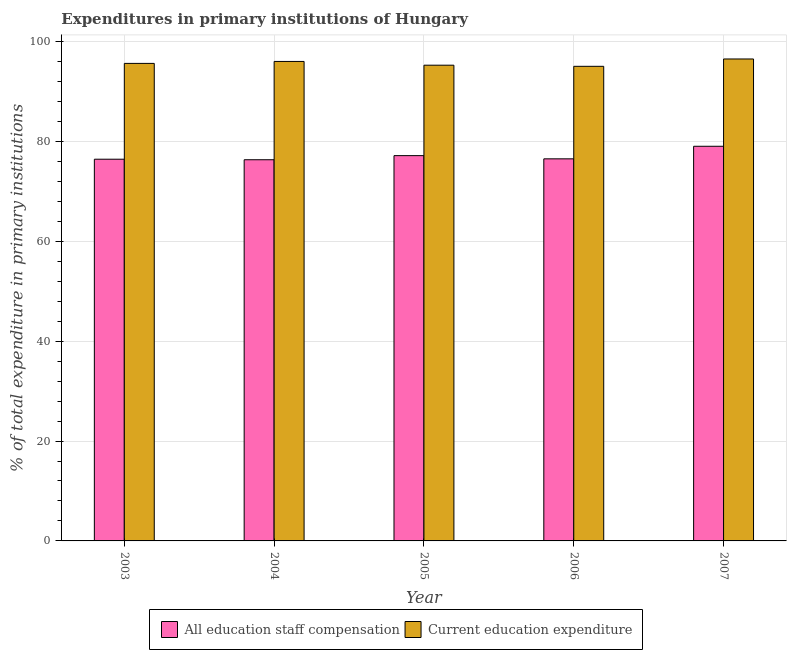How many different coloured bars are there?
Your answer should be compact. 2. Are the number of bars per tick equal to the number of legend labels?
Your answer should be compact. Yes. What is the label of the 1st group of bars from the left?
Your answer should be compact. 2003. What is the expenditure in staff compensation in 2006?
Your response must be concise. 76.5. Across all years, what is the maximum expenditure in education?
Your answer should be very brief. 96.49. Across all years, what is the minimum expenditure in staff compensation?
Offer a very short reply. 76.32. In which year was the expenditure in education maximum?
Keep it short and to the point. 2007. In which year was the expenditure in staff compensation minimum?
Your answer should be compact. 2004. What is the total expenditure in education in the graph?
Keep it short and to the point. 478.37. What is the difference between the expenditure in staff compensation in 2004 and that in 2005?
Keep it short and to the point. -0.82. What is the difference between the expenditure in education in 2003 and the expenditure in staff compensation in 2006?
Your response must be concise. 0.58. What is the average expenditure in education per year?
Keep it short and to the point. 95.67. What is the ratio of the expenditure in education in 2004 to that in 2006?
Provide a succinct answer. 1.01. What is the difference between the highest and the second highest expenditure in education?
Offer a very short reply. 0.49. What is the difference between the highest and the lowest expenditure in education?
Your response must be concise. 1.47. What does the 1st bar from the left in 2007 represents?
Ensure brevity in your answer.  All education staff compensation. What does the 2nd bar from the right in 2005 represents?
Your answer should be very brief. All education staff compensation. How many years are there in the graph?
Keep it short and to the point. 5. What is the difference between two consecutive major ticks on the Y-axis?
Offer a terse response. 20. Does the graph contain grids?
Provide a succinct answer. Yes. What is the title of the graph?
Make the answer very short. Expenditures in primary institutions of Hungary. What is the label or title of the Y-axis?
Provide a short and direct response. % of total expenditure in primary institutions. What is the % of total expenditure in primary institutions in All education staff compensation in 2003?
Make the answer very short. 76.42. What is the % of total expenditure in primary institutions of Current education expenditure in 2003?
Ensure brevity in your answer.  95.61. What is the % of total expenditure in primary institutions in All education staff compensation in 2004?
Your response must be concise. 76.32. What is the % of total expenditure in primary institutions of Current education expenditure in 2004?
Your response must be concise. 96. What is the % of total expenditure in primary institutions of All education staff compensation in 2005?
Make the answer very short. 77.14. What is the % of total expenditure in primary institutions in Current education expenditure in 2005?
Your answer should be very brief. 95.25. What is the % of total expenditure in primary institutions in All education staff compensation in 2006?
Ensure brevity in your answer.  76.5. What is the % of total expenditure in primary institutions of Current education expenditure in 2006?
Make the answer very short. 95.02. What is the % of total expenditure in primary institutions in All education staff compensation in 2007?
Provide a succinct answer. 79.01. What is the % of total expenditure in primary institutions in Current education expenditure in 2007?
Keep it short and to the point. 96.49. Across all years, what is the maximum % of total expenditure in primary institutions in All education staff compensation?
Give a very brief answer. 79.01. Across all years, what is the maximum % of total expenditure in primary institutions of Current education expenditure?
Your response must be concise. 96.49. Across all years, what is the minimum % of total expenditure in primary institutions of All education staff compensation?
Offer a terse response. 76.32. Across all years, what is the minimum % of total expenditure in primary institutions in Current education expenditure?
Provide a succinct answer. 95.02. What is the total % of total expenditure in primary institutions in All education staff compensation in the graph?
Make the answer very short. 385.39. What is the total % of total expenditure in primary institutions in Current education expenditure in the graph?
Keep it short and to the point. 478.37. What is the difference between the % of total expenditure in primary institutions of All education staff compensation in 2003 and that in 2004?
Provide a succinct answer. 0.11. What is the difference between the % of total expenditure in primary institutions of Current education expenditure in 2003 and that in 2004?
Your answer should be very brief. -0.39. What is the difference between the % of total expenditure in primary institutions of All education staff compensation in 2003 and that in 2005?
Keep it short and to the point. -0.72. What is the difference between the % of total expenditure in primary institutions in Current education expenditure in 2003 and that in 2005?
Provide a short and direct response. 0.36. What is the difference between the % of total expenditure in primary institutions of All education staff compensation in 2003 and that in 2006?
Keep it short and to the point. -0.07. What is the difference between the % of total expenditure in primary institutions of Current education expenditure in 2003 and that in 2006?
Make the answer very short. 0.58. What is the difference between the % of total expenditure in primary institutions in All education staff compensation in 2003 and that in 2007?
Provide a short and direct response. -2.59. What is the difference between the % of total expenditure in primary institutions in Current education expenditure in 2003 and that in 2007?
Ensure brevity in your answer.  -0.89. What is the difference between the % of total expenditure in primary institutions in All education staff compensation in 2004 and that in 2005?
Make the answer very short. -0.82. What is the difference between the % of total expenditure in primary institutions of Current education expenditure in 2004 and that in 2005?
Your answer should be compact. 0.75. What is the difference between the % of total expenditure in primary institutions of All education staff compensation in 2004 and that in 2006?
Keep it short and to the point. -0.18. What is the difference between the % of total expenditure in primary institutions in Current education expenditure in 2004 and that in 2006?
Your answer should be compact. 0.98. What is the difference between the % of total expenditure in primary institutions of All education staff compensation in 2004 and that in 2007?
Give a very brief answer. -2.7. What is the difference between the % of total expenditure in primary institutions of Current education expenditure in 2004 and that in 2007?
Your answer should be compact. -0.49. What is the difference between the % of total expenditure in primary institutions in All education staff compensation in 2005 and that in 2006?
Offer a very short reply. 0.64. What is the difference between the % of total expenditure in primary institutions in Current education expenditure in 2005 and that in 2006?
Give a very brief answer. 0.22. What is the difference between the % of total expenditure in primary institutions in All education staff compensation in 2005 and that in 2007?
Provide a succinct answer. -1.87. What is the difference between the % of total expenditure in primary institutions in Current education expenditure in 2005 and that in 2007?
Offer a very short reply. -1.25. What is the difference between the % of total expenditure in primary institutions in All education staff compensation in 2006 and that in 2007?
Ensure brevity in your answer.  -2.52. What is the difference between the % of total expenditure in primary institutions in Current education expenditure in 2006 and that in 2007?
Your answer should be very brief. -1.47. What is the difference between the % of total expenditure in primary institutions of All education staff compensation in 2003 and the % of total expenditure in primary institutions of Current education expenditure in 2004?
Give a very brief answer. -19.58. What is the difference between the % of total expenditure in primary institutions of All education staff compensation in 2003 and the % of total expenditure in primary institutions of Current education expenditure in 2005?
Your answer should be compact. -18.82. What is the difference between the % of total expenditure in primary institutions of All education staff compensation in 2003 and the % of total expenditure in primary institutions of Current education expenditure in 2006?
Ensure brevity in your answer.  -18.6. What is the difference between the % of total expenditure in primary institutions in All education staff compensation in 2003 and the % of total expenditure in primary institutions in Current education expenditure in 2007?
Your response must be concise. -20.07. What is the difference between the % of total expenditure in primary institutions in All education staff compensation in 2004 and the % of total expenditure in primary institutions in Current education expenditure in 2005?
Give a very brief answer. -18.93. What is the difference between the % of total expenditure in primary institutions of All education staff compensation in 2004 and the % of total expenditure in primary institutions of Current education expenditure in 2006?
Your response must be concise. -18.71. What is the difference between the % of total expenditure in primary institutions of All education staff compensation in 2004 and the % of total expenditure in primary institutions of Current education expenditure in 2007?
Make the answer very short. -20.18. What is the difference between the % of total expenditure in primary institutions of All education staff compensation in 2005 and the % of total expenditure in primary institutions of Current education expenditure in 2006?
Ensure brevity in your answer.  -17.88. What is the difference between the % of total expenditure in primary institutions of All education staff compensation in 2005 and the % of total expenditure in primary institutions of Current education expenditure in 2007?
Give a very brief answer. -19.35. What is the difference between the % of total expenditure in primary institutions in All education staff compensation in 2006 and the % of total expenditure in primary institutions in Current education expenditure in 2007?
Your answer should be very brief. -20. What is the average % of total expenditure in primary institutions of All education staff compensation per year?
Make the answer very short. 77.08. What is the average % of total expenditure in primary institutions in Current education expenditure per year?
Provide a short and direct response. 95.67. In the year 2003, what is the difference between the % of total expenditure in primary institutions of All education staff compensation and % of total expenditure in primary institutions of Current education expenditure?
Provide a short and direct response. -19.18. In the year 2004, what is the difference between the % of total expenditure in primary institutions of All education staff compensation and % of total expenditure in primary institutions of Current education expenditure?
Ensure brevity in your answer.  -19.68. In the year 2005, what is the difference between the % of total expenditure in primary institutions of All education staff compensation and % of total expenditure in primary institutions of Current education expenditure?
Give a very brief answer. -18.11. In the year 2006, what is the difference between the % of total expenditure in primary institutions in All education staff compensation and % of total expenditure in primary institutions in Current education expenditure?
Your response must be concise. -18.53. In the year 2007, what is the difference between the % of total expenditure in primary institutions of All education staff compensation and % of total expenditure in primary institutions of Current education expenditure?
Ensure brevity in your answer.  -17.48. What is the ratio of the % of total expenditure in primary institutions of Current education expenditure in 2003 to that in 2005?
Provide a succinct answer. 1. What is the ratio of the % of total expenditure in primary institutions of Current education expenditure in 2003 to that in 2006?
Provide a succinct answer. 1.01. What is the ratio of the % of total expenditure in primary institutions of All education staff compensation in 2003 to that in 2007?
Your answer should be very brief. 0.97. What is the ratio of the % of total expenditure in primary institutions of Current education expenditure in 2003 to that in 2007?
Your response must be concise. 0.99. What is the ratio of the % of total expenditure in primary institutions of All education staff compensation in 2004 to that in 2005?
Keep it short and to the point. 0.99. What is the ratio of the % of total expenditure in primary institutions of Current education expenditure in 2004 to that in 2005?
Your response must be concise. 1.01. What is the ratio of the % of total expenditure in primary institutions of All education staff compensation in 2004 to that in 2006?
Give a very brief answer. 1. What is the ratio of the % of total expenditure in primary institutions in Current education expenditure in 2004 to that in 2006?
Your answer should be compact. 1.01. What is the ratio of the % of total expenditure in primary institutions of All education staff compensation in 2004 to that in 2007?
Your answer should be very brief. 0.97. What is the ratio of the % of total expenditure in primary institutions of All education staff compensation in 2005 to that in 2006?
Your response must be concise. 1.01. What is the ratio of the % of total expenditure in primary institutions in Current education expenditure in 2005 to that in 2006?
Provide a short and direct response. 1. What is the ratio of the % of total expenditure in primary institutions of All education staff compensation in 2005 to that in 2007?
Provide a short and direct response. 0.98. What is the ratio of the % of total expenditure in primary institutions in Current education expenditure in 2005 to that in 2007?
Give a very brief answer. 0.99. What is the ratio of the % of total expenditure in primary institutions of All education staff compensation in 2006 to that in 2007?
Your answer should be very brief. 0.97. What is the difference between the highest and the second highest % of total expenditure in primary institutions in All education staff compensation?
Make the answer very short. 1.87. What is the difference between the highest and the second highest % of total expenditure in primary institutions in Current education expenditure?
Your answer should be very brief. 0.49. What is the difference between the highest and the lowest % of total expenditure in primary institutions of All education staff compensation?
Keep it short and to the point. 2.7. What is the difference between the highest and the lowest % of total expenditure in primary institutions in Current education expenditure?
Your answer should be compact. 1.47. 